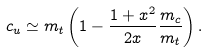Convert formula to latex. <formula><loc_0><loc_0><loc_500><loc_500>c _ { u } \simeq m _ { t } \left ( 1 - \frac { 1 + x ^ { 2 } } { 2 x } \frac { m _ { c } } { m _ { t } } \right ) .</formula> 